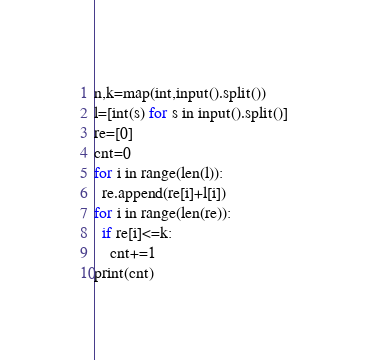Convert code to text. <code><loc_0><loc_0><loc_500><loc_500><_Python_>n,k=map(int,input().split())
l=[int(s) for s in input().split()]
re=[0]
cnt=0
for i in range(len(l)):
  re.append(re[i]+l[i])
for i in range(len(re)):
  if re[i]<=k:
    cnt+=1
print(cnt)</code> 